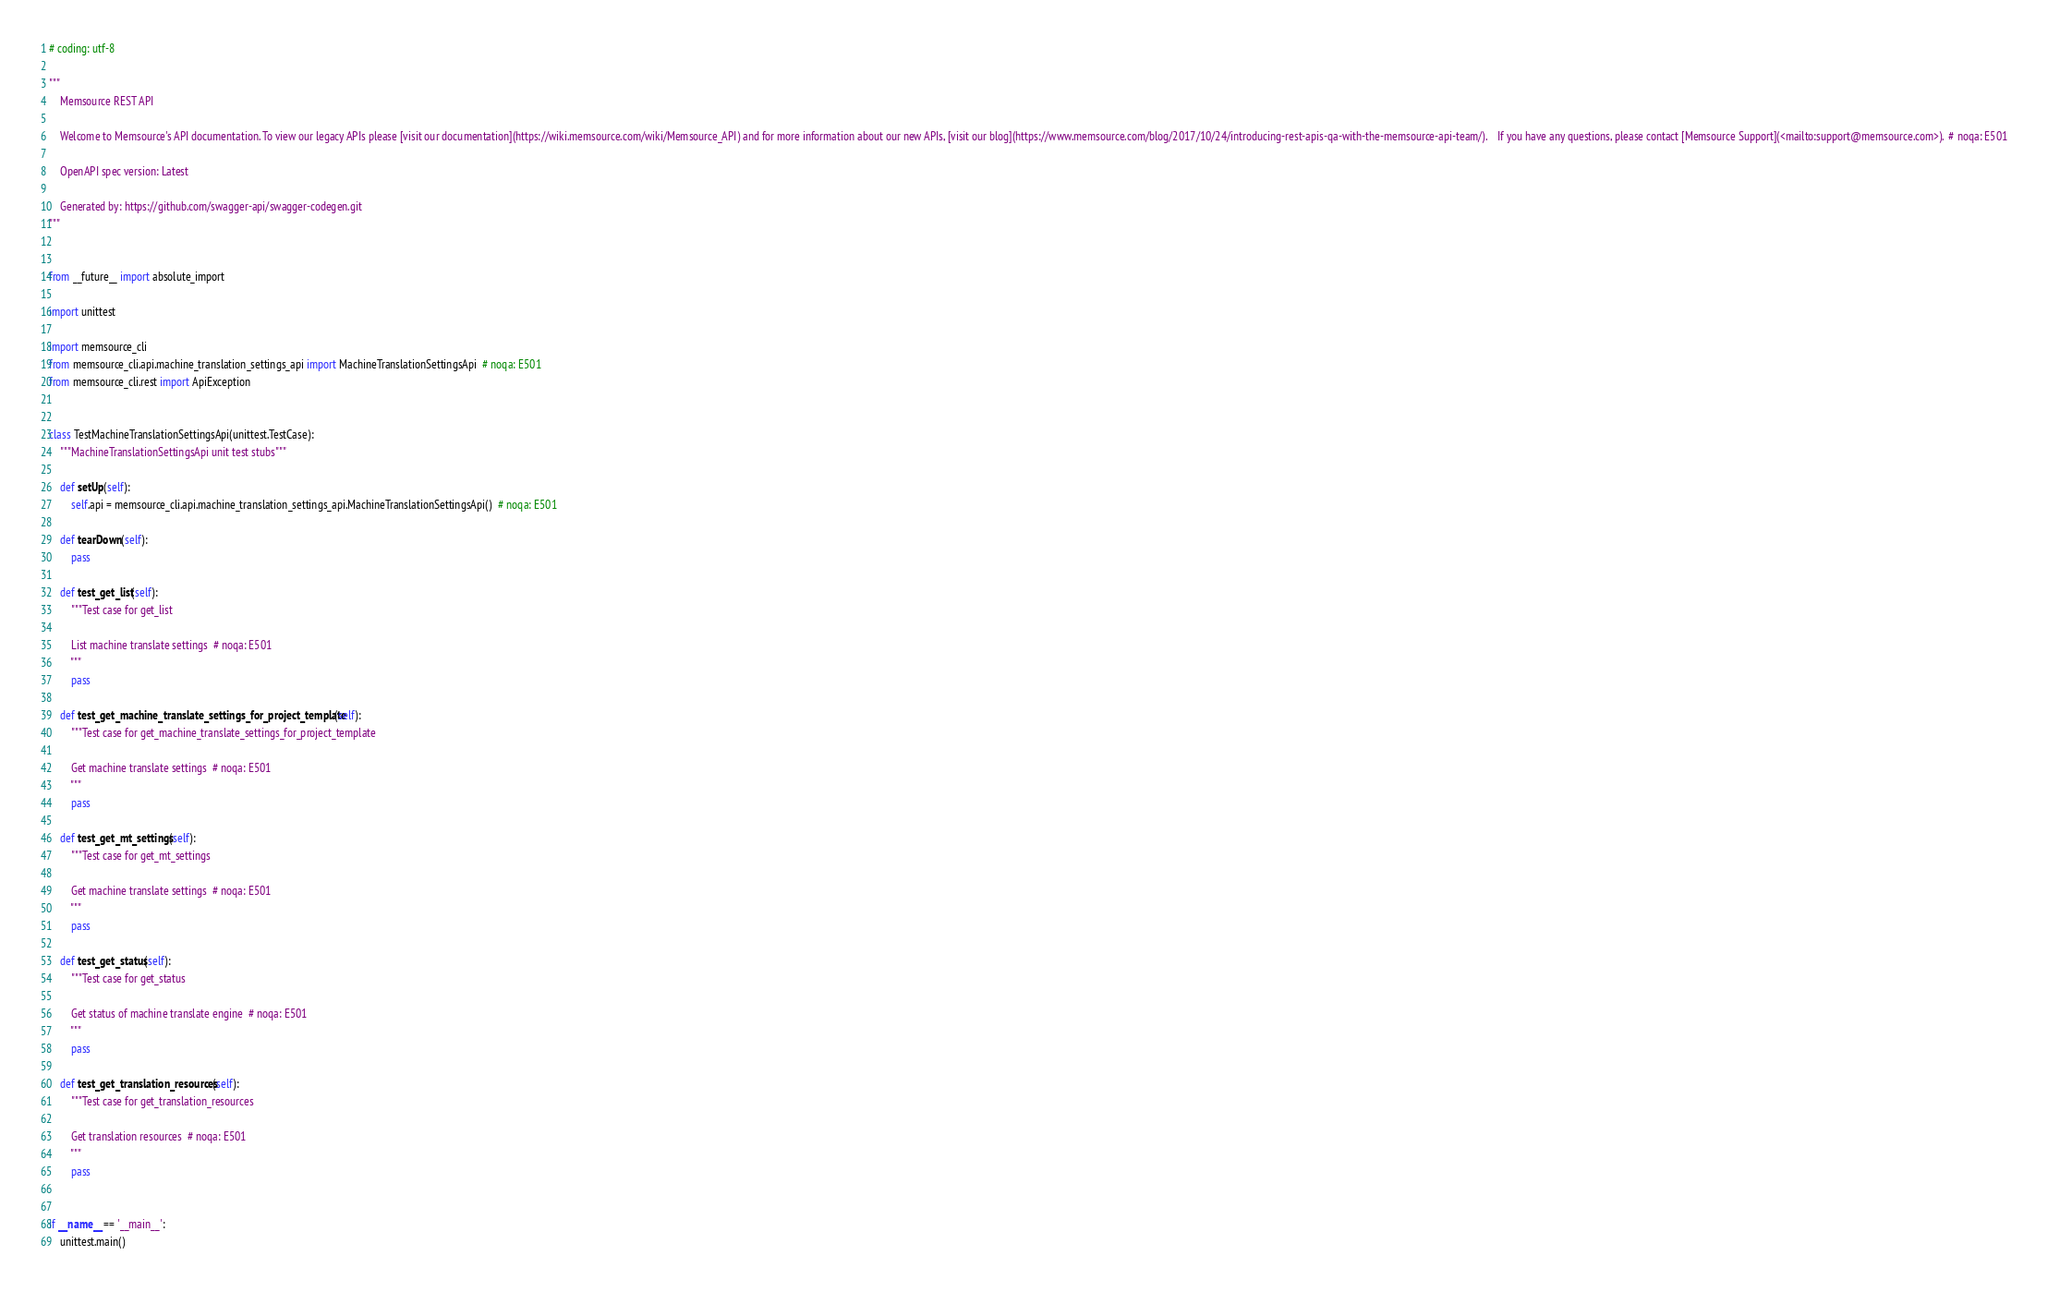Convert code to text. <code><loc_0><loc_0><loc_500><loc_500><_Python_># coding: utf-8

"""
    Memsource REST API

    Welcome to Memsource's API documentation. To view our legacy APIs please [visit our documentation](https://wiki.memsource.com/wiki/Memsource_API) and for more information about our new APIs, [visit our blog](https://www.memsource.com/blog/2017/10/24/introducing-rest-apis-qa-with-the-memsource-api-team/).    If you have any questions, please contact [Memsource Support](<mailto:support@memsource.com>).  # noqa: E501

    OpenAPI spec version: Latest
    
    Generated by: https://github.com/swagger-api/swagger-codegen.git
"""


from __future__ import absolute_import

import unittest

import memsource_cli
from memsource_cli.api.machine_translation_settings_api import MachineTranslationSettingsApi  # noqa: E501
from memsource_cli.rest import ApiException


class TestMachineTranslationSettingsApi(unittest.TestCase):
    """MachineTranslationSettingsApi unit test stubs"""

    def setUp(self):
        self.api = memsource_cli.api.machine_translation_settings_api.MachineTranslationSettingsApi()  # noqa: E501

    def tearDown(self):
        pass

    def test_get_list(self):
        """Test case for get_list

        List machine translate settings  # noqa: E501
        """
        pass

    def test_get_machine_translate_settings_for_project_template(self):
        """Test case for get_machine_translate_settings_for_project_template

        Get machine translate settings  # noqa: E501
        """
        pass

    def test_get_mt_settings(self):
        """Test case for get_mt_settings

        Get machine translate settings  # noqa: E501
        """
        pass

    def test_get_status(self):
        """Test case for get_status

        Get status of machine translate engine  # noqa: E501
        """
        pass

    def test_get_translation_resources(self):
        """Test case for get_translation_resources

        Get translation resources  # noqa: E501
        """
        pass


if __name__ == '__main__':
    unittest.main()
</code> 